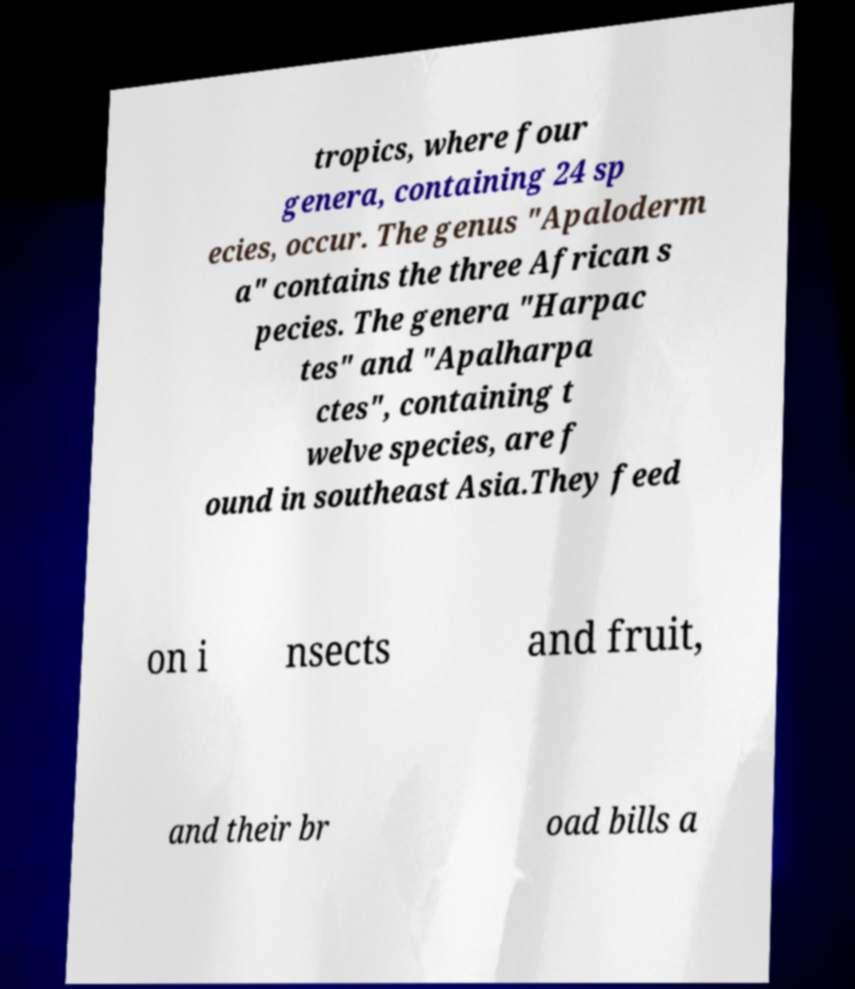There's text embedded in this image that I need extracted. Can you transcribe it verbatim? tropics, where four genera, containing 24 sp ecies, occur. The genus "Apaloderm a" contains the three African s pecies. The genera "Harpac tes" and "Apalharpa ctes", containing t welve species, are f ound in southeast Asia.They feed on i nsects and fruit, and their br oad bills a 